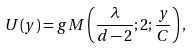<formula> <loc_0><loc_0><loc_500><loc_500>U ( y ) = g M \left ( \frac { \lambda } { d - 2 } ; 2 ; \frac { y } { C } \right ) ,</formula> 